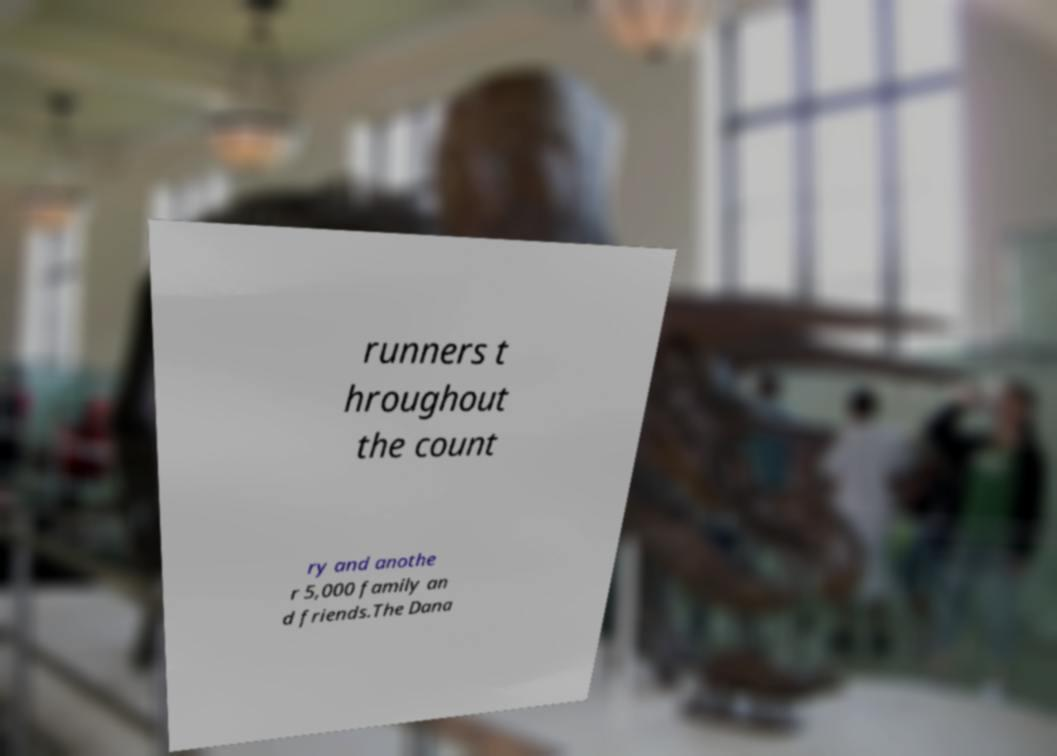Please identify and transcribe the text found in this image. runners t hroughout the count ry and anothe r 5,000 family an d friends.The Dana 